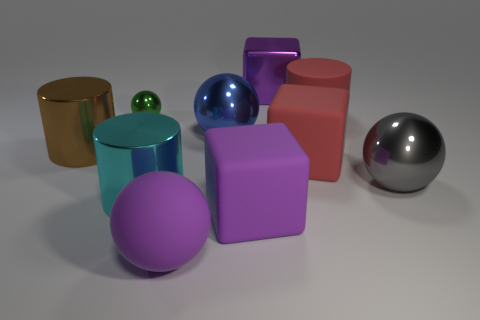Subtract all small green metallic spheres. How many spheres are left? 3 Subtract all gray spheres. How many purple blocks are left? 2 Subtract 1 spheres. How many spheres are left? 3 Subtract all red cylinders. How many cylinders are left? 2 Add 1 small yellow rubber objects. How many small yellow rubber objects exist? 1 Subtract 0 green cylinders. How many objects are left? 10 Subtract all blocks. How many objects are left? 7 Subtract all blue cylinders. Subtract all gray spheres. How many cylinders are left? 3 Subtract all tiny green spheres. Subtract all red things. How many objects are left? 7 Add 2 large blue metal balls. How many large blue metal balls are left? 3 